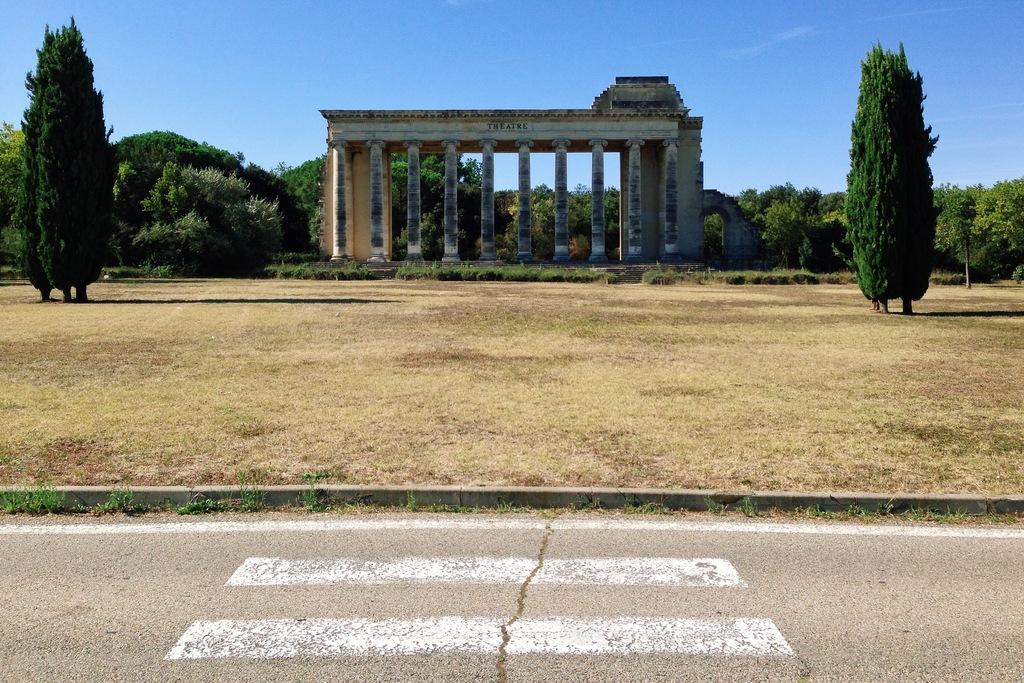What is the main subject of the picture? The main subject of the picture is a monument. What can be seen around the monument? There are trees and grass around the monument. Is there any indication of a path or route in the image? Yes, there is a road in front of the grass surface. How much tax is being paid for the monument in the image? There is no information about tax in the image, as it focuses on the monument and its surroundings. 